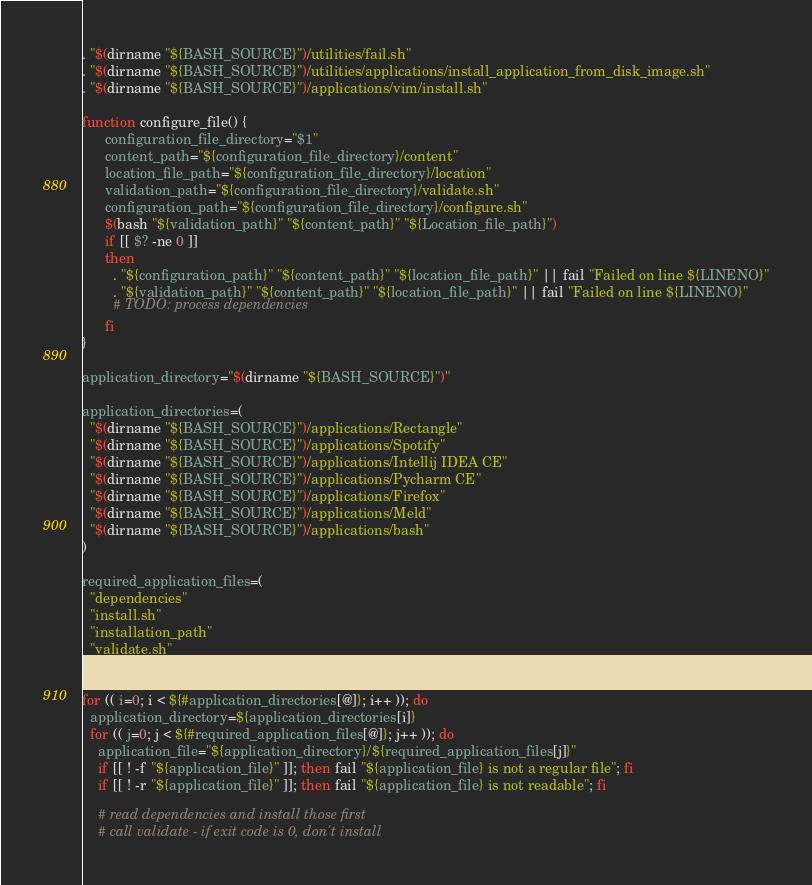Convert code to text. <code><loc_0><loc_0><loc_500><loc_500><_Bash_>
. "$(dirname "${BASH_SOURCE}")/utilities/fail.sh"
. "$(dirname "${BASH_SOURCE}")/utilities/applications/install_application_from_disk_image.sh"
. "$(dirname "${BASH_SOURCE}")/applications/vim/install.sh"

function configure_file() {
      configuration_file_directory="$1"
      content_path="${configuration_file_directory}/content"
      location_file_path="${configuration_file_directory}/location"
      validation_path="${configuration_file_directory}/validate.sh"
      configuration_path="${configuration_file_directory}/configure.sh"
      $(bash "${validation_path}" "${content_path}" "${Location_file_path}")
      if [[ $? -ne 0 ]]
      then
        . "${configuration_path}" "${content_path}" "${location_file_path}" || fail "Failed on line ${LINENO}"
        . "${validation_path}" "${content_path}" "${location_file_path}" || fail "Failed on line ${LINENO}"
        # TODO: process dependencies
      fi
}

application_directory="$(dirname "${BASH_SOURCE}")"

application_directories=(
  "$(dirname "${BASH_SOURCE}")/applications/Rectangle"
  "$(dirname "${BASH_SOURCE}")/applications/Spotify"
  "$(dirname "${BASH_SOURCE}")/applications/Intellij IDEA CE"
  "$(dirname "${BASH_SOURCE}")/applications/Pycharm CE"
  "$(dirname "${BASH_SOURCE}")/applications/Firefox"
  "$(dirname "${BASH_SOURCE}")/applications/Meld"
  "$(dirname "${BASH_SOURCE}")/applications/bash"
)

required_application_files=(
  "dependencies"
  "install.sh"
  "installation_path"
  "validate.sh"
)

for (( i=0; i < ${#application_directories[@]}; i++ )); do
  application_directory=${application_directories[i]}
  for (( j=0; j < ${#required_application_files[@]}; j++ )); do
    application_file="${application_directory}/${required_application_files[j]}"
    if [[ ! -f "${application_file}" ]]; then fail "${application_file} is not a regular file"; fi
    if [[ ! -r "${application_file}" ]]; then fail "${application_file} is not readable"; fi

    # read dependencies and install those first
    # call validate - if exit code is 0, don't install</code> 